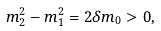Convert formula to latex. <formula><loc_0><loc_0><loc_500><loc_500>m _ { 2 } ^ { 2 } - m _ { 1 } ^ { 2 } = 2 \delta m _ { 0 } > 0 ,</formula> 